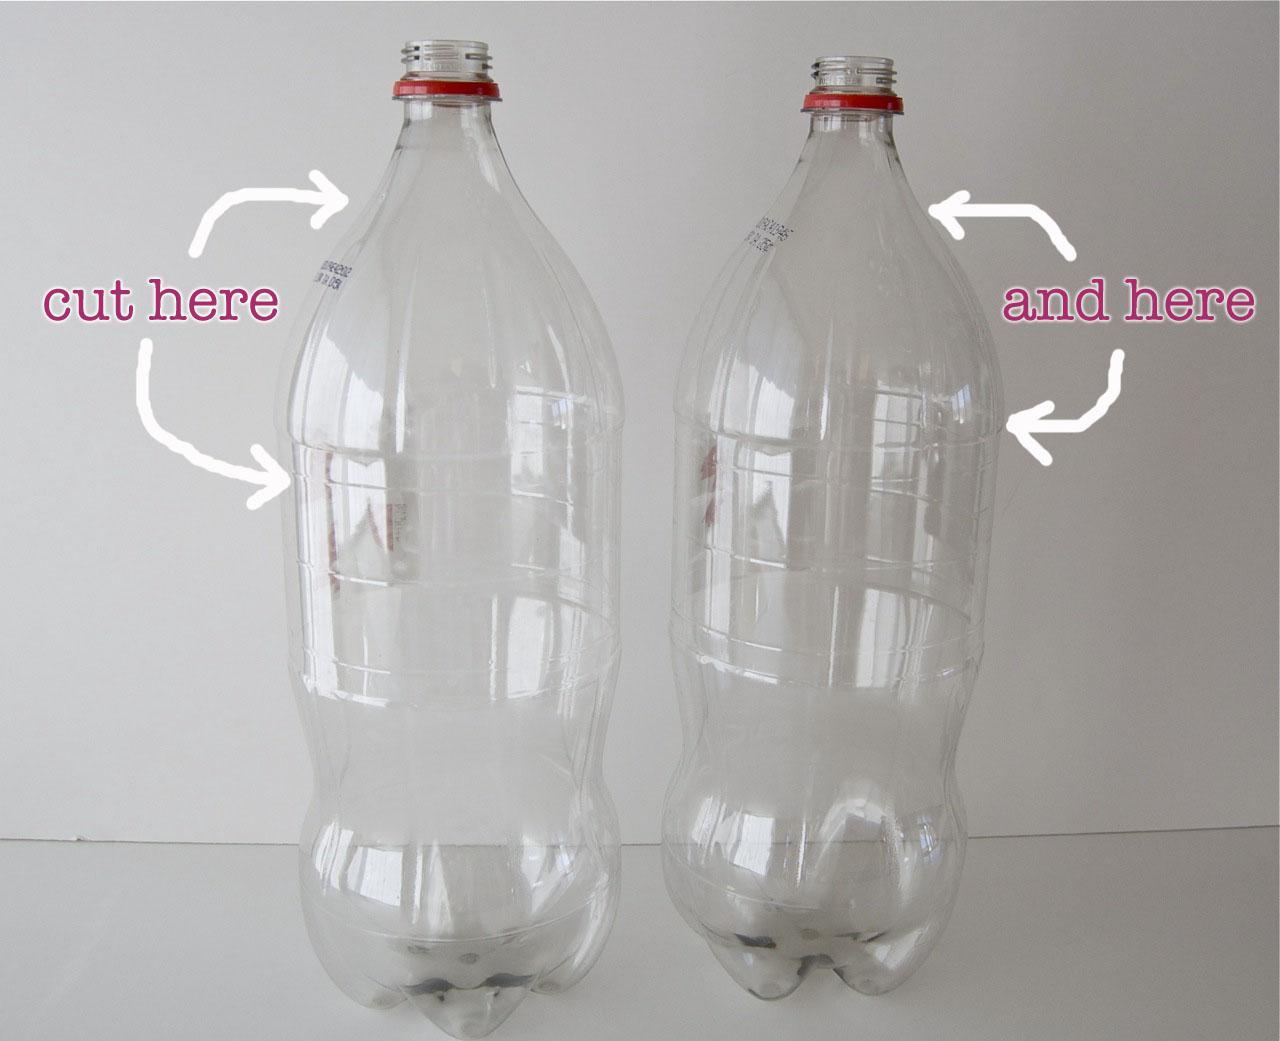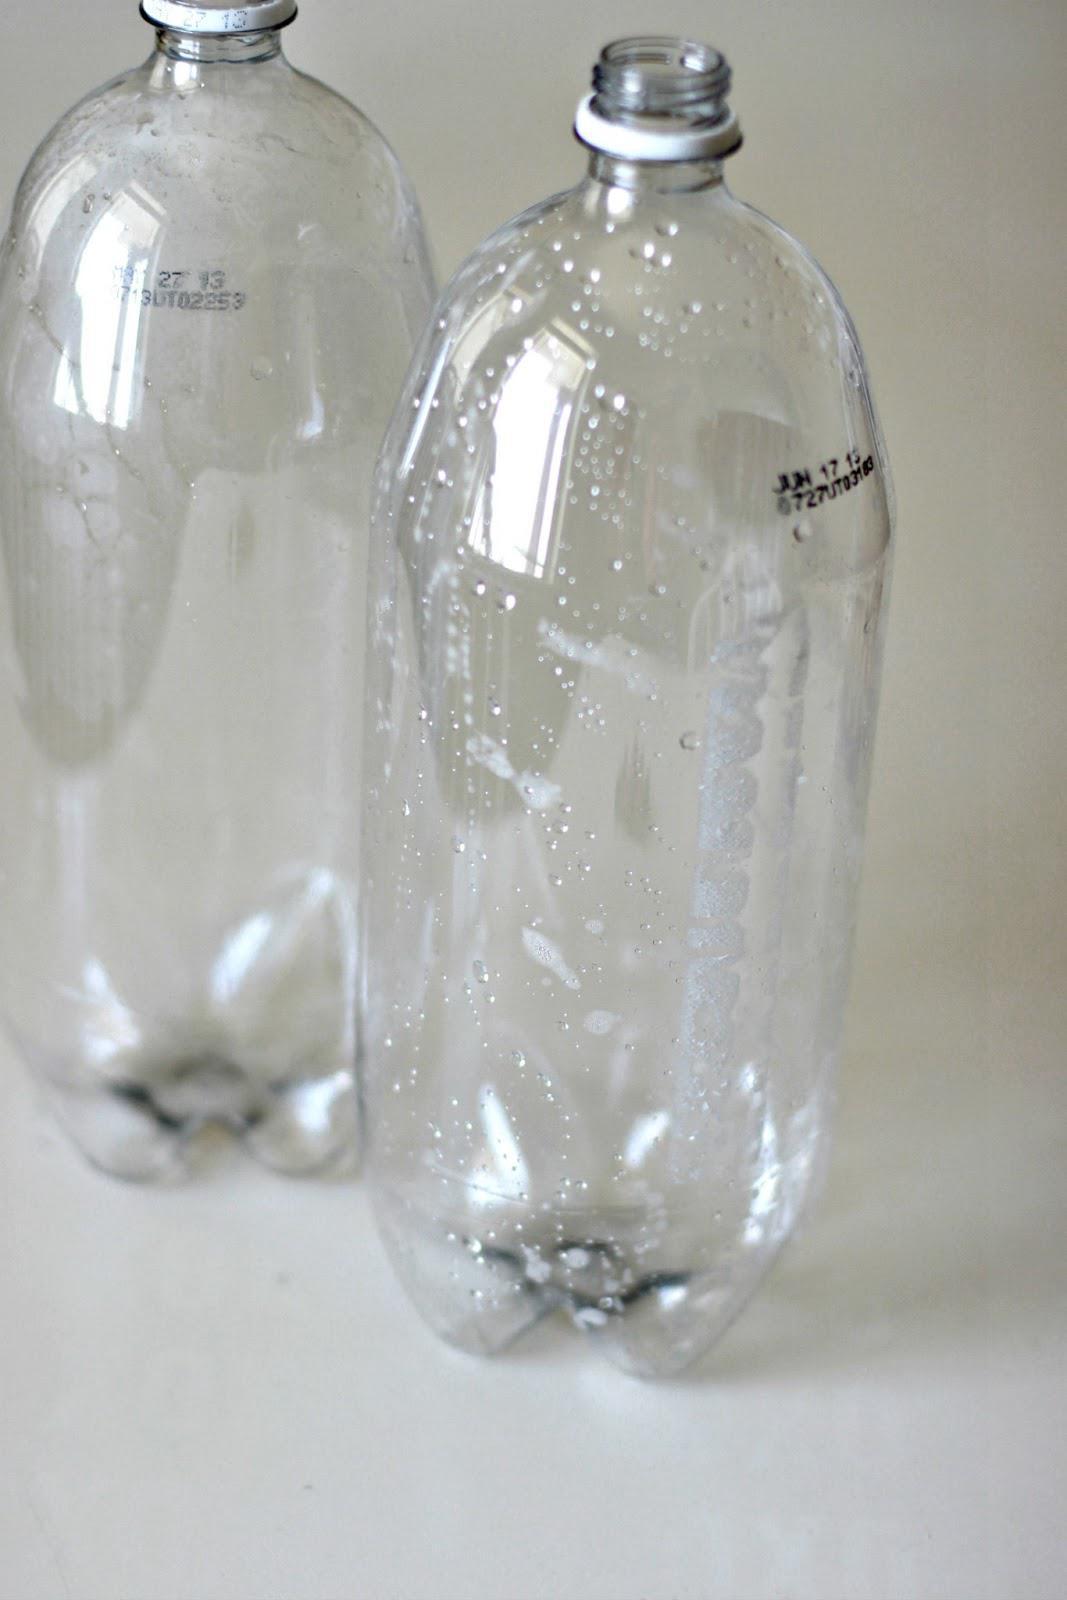The first image is the image on the left, the second image is the image on the right. Evaluate the accuracy of this statement regarding the images: "At least two bottles have caps on them.". Is it true? Answer yes or no. No. The first image is the image on the left, the second image is the image on the right. For the images shown, is this caption "One of the pictures shows at least two bottles standing upright side by side." true? Answer yes or no. Yes. 